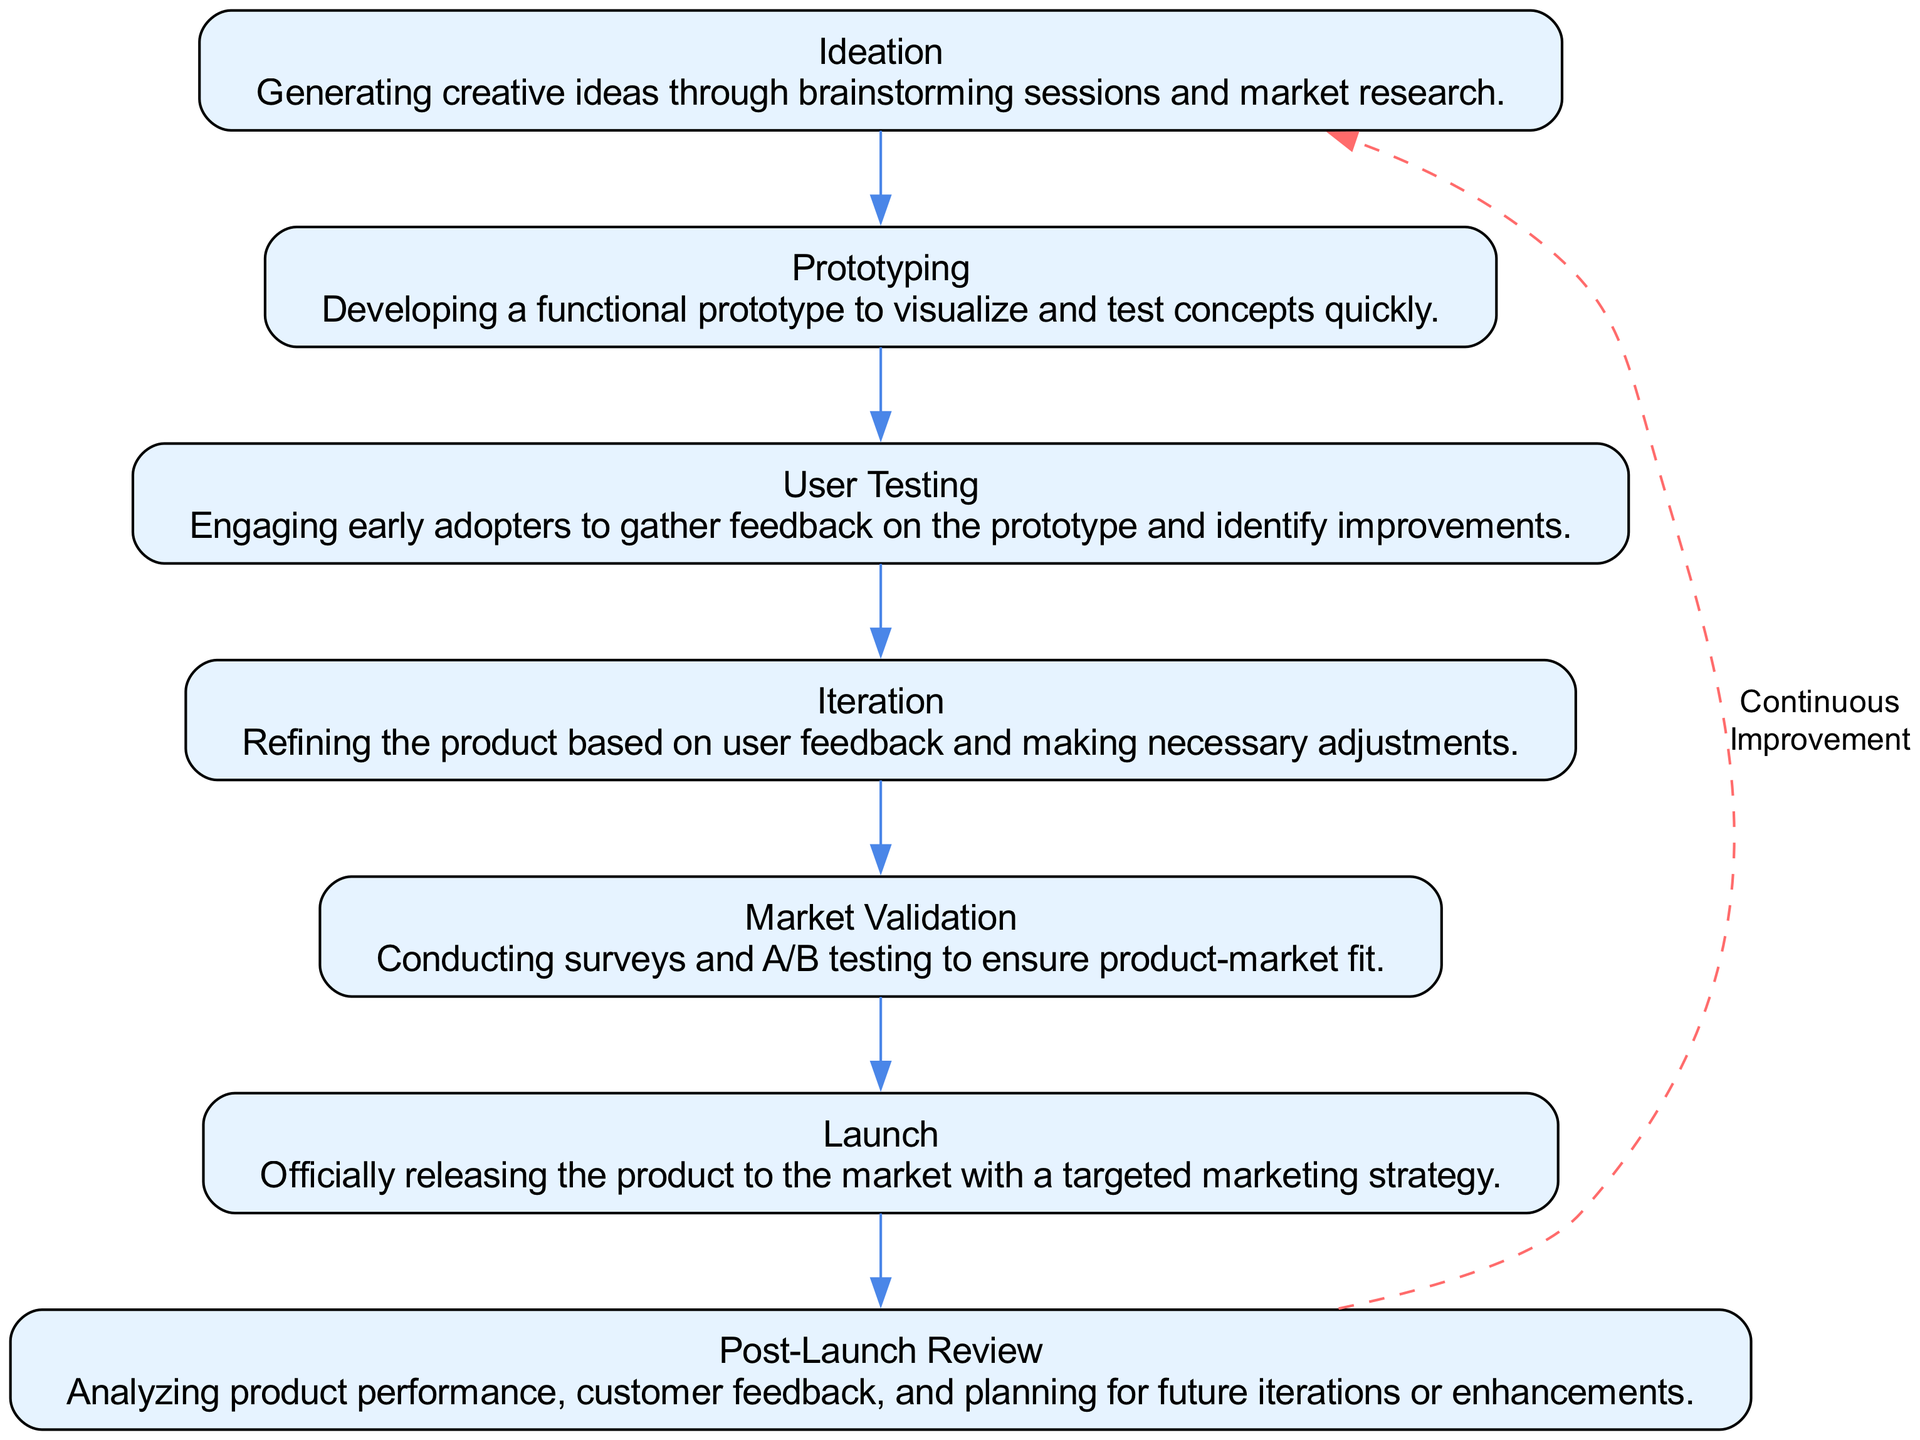What is the first stage in the lifecycle? The first stage in the diagram is labeled "Ideation". This can be found at the top of the flow chart, indicating the starting point of the innovative product development lifecycle.
Answer: Ideation How many stages are there in total? There are 7 stages indicated in the diagram, as listed consecutively from "Ideation" to "Post-Launch Review". The count can be confirmed by observing each node representing a stage.
Answer: 7 What does the "Iteration" stage focus on? The "Iteration" stage is focused on refining the product based on user feedback. This is described directly in the node designated for the "Iteration" step, summarizing the key activity of that phase.
Answer: Refining the product based on user feedback Which stage comes immediately before "Launch"? "Market Validation" comes immediately before "Launch" in the flow chart. This relationship can be seen as the two stages are connected directly by an arrow from "Market Validation" to "Launch".
Answer: Market Validation What symbolic relationship exists between the "Post-Launch Review" and "Ideation"? There is a dashed edge labeled "Continuous Improvement" connecting "Post-Launch Review" back to "Ideation", indicating a cyclical relationship between these stages, suggesting that the process is iterative and that insights from post-launch can lead to new ideas in ideation.
Answer: Continuous Improvement Which stage involves engaging early adopters? The stage that involves engaging early adopters is "User Testing", as stated in the description within that specific node. This highlights the importance of user feedback at this point in the process.
Answer: User Testing What does the "Launch" stage include? The "Launch" stage includes the official release of the product to the market with a targeted marketing strategy, as described in the corresponding node. This provides key information about what this phase encompasses.
Answer: Officially releasing the product How is the relationship between "Prototyping" and "User Testing" characterized? The relationship between "Prototyping" and "User Testing" is characterized as a direct progression with an edge connecting them, indicating that after prototyping, the next logical step is user testing to gather feedback on the prototype.
Answer: Direct progression What is the primary outcome expected from the "Market Validation" stage? The primary outcome expected from the "Market Validation" stage is to ensure product-market fit, which aims to validate the product's acceptance in the market based on testing and surveys. This goal is explicitly stated in the node associated with "Market Validation".
Answer: Ensure product-market fit 